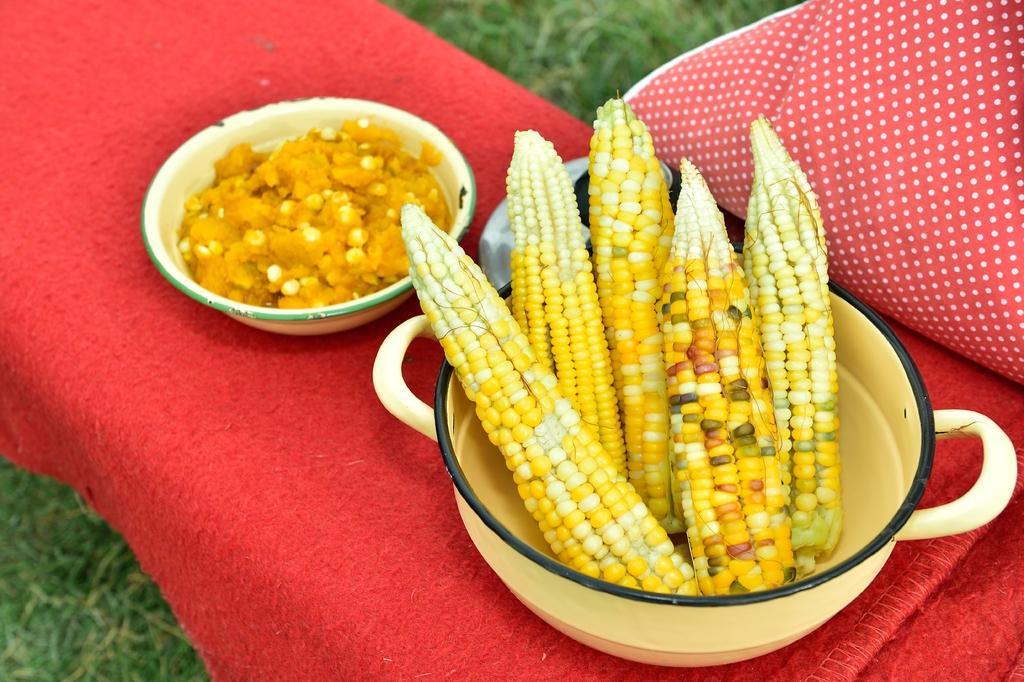In one or two sentences, can you explain what this image depicts? In this image I can see corn in a dish on a table. I can see a food item in a bowl on the table. 